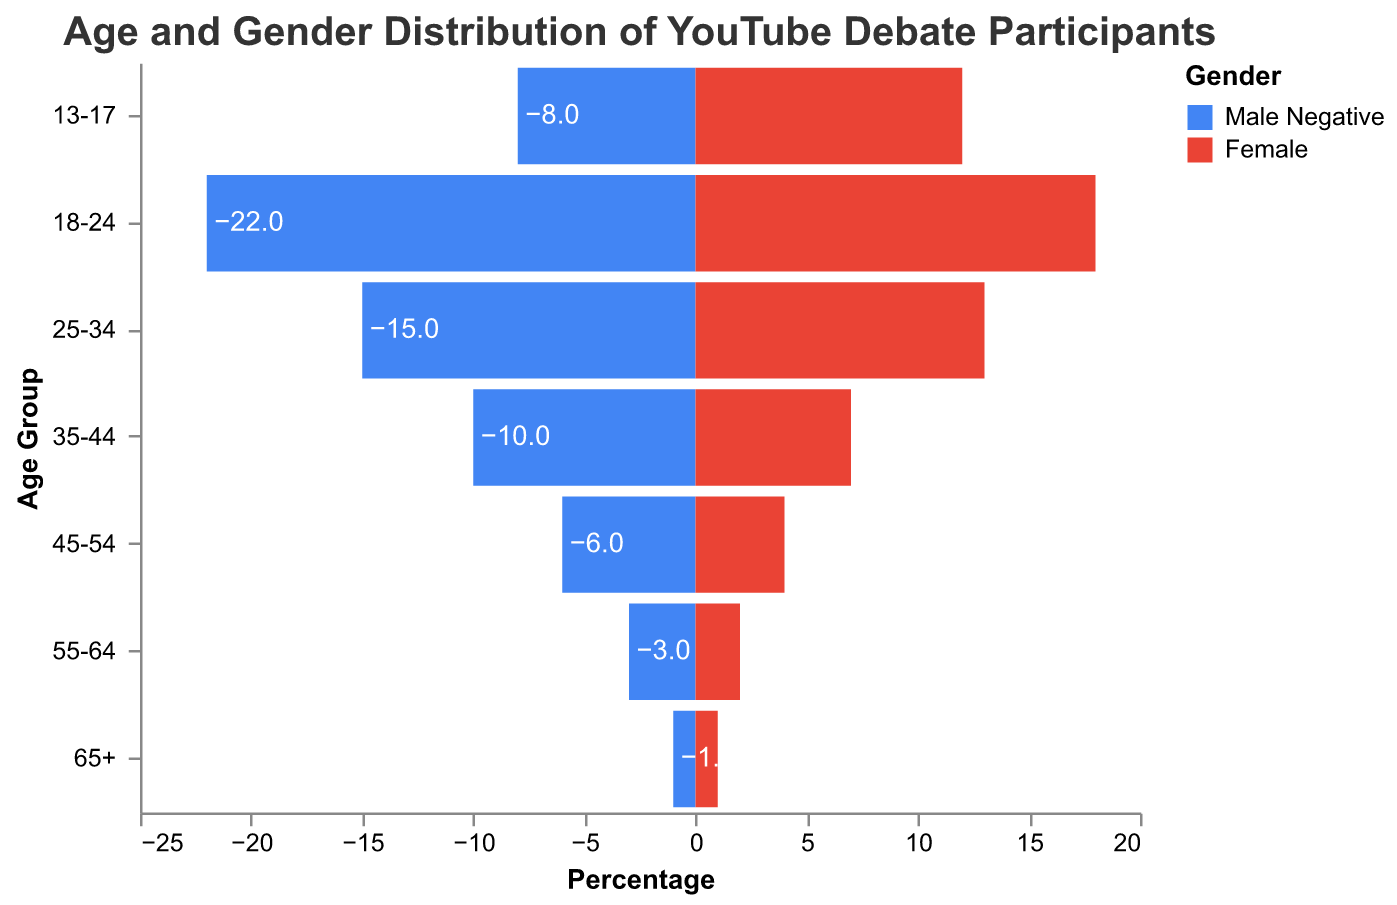How many age groups are listed in the figure? Count the number of distinct age ranges displayed on the y-axis.
Answer: 7 Which gender has more participants in the 18-24 age group? Compare the values for Male and Female participants within the 18-24 age group. Male has 22 participants, and Female has 18.
Answer: Male What is the total number of female participants in the age groups 35-44 and 45-54? Add the number of Female participants in the 35-44 age group (7) and the 45-54 age group (4). That’s 7 + 4.
Answer: 11 Which age group has the least number of male participants? Look at the values for Male participants across all age groups and find the minimum. The smallest value is 1 in the 65+ age group.
Answer: 65+ Compare the participation of females in the age groups 13-17 and 55-64. Which group has more participants? Compare the values for Female participants in the 13-17 age group (12) and the 55-64 age group (2).
Answer: 13-17 What is the difference in the number of male and female participants in the 25-34 age group? Subtract the number of Female participants (13) from Male participants (15) in the 25-34 age group. That’s 15 - 13.
Answer: 2 What is the total number of participants in the 18-24 age group? Add the number of Male (22) and Female (18) participants in the 18-24 age group. That’s 22 + 18.
Answer: 40 Rank the age groups from highest to lowest based on the number of female participants. List the number of Female participants in each age group and sort them in descending order: 13-17 (12), 18-24 (18), 25-34 (13), 35-44 (7), 45-54 (4), 55-64 (2), 65+ (1).
Answer: 18-24, 13-17, 25-34, 35-44, 45-54, 55-64, 65+ What percentage of the total participants are in the 55-64 age group? First find the total number of participants by summing all Male and Female values. Total participants = 8+12+22+18+15+13+10+7+6+4+3+2+1+1 = 122. Then sum the participants in the 55-64 age group: 3+2 = 5. Finally, calculate (5/122)*100 to get the percentage.
Answer: 4.1% What is the average number of male participants across all age groups? Sum the number of Male participants across all age groups and divide by the number of age groups. That’s (8+22+15+10+6+3+1) / 7.
Answer: 9.3 